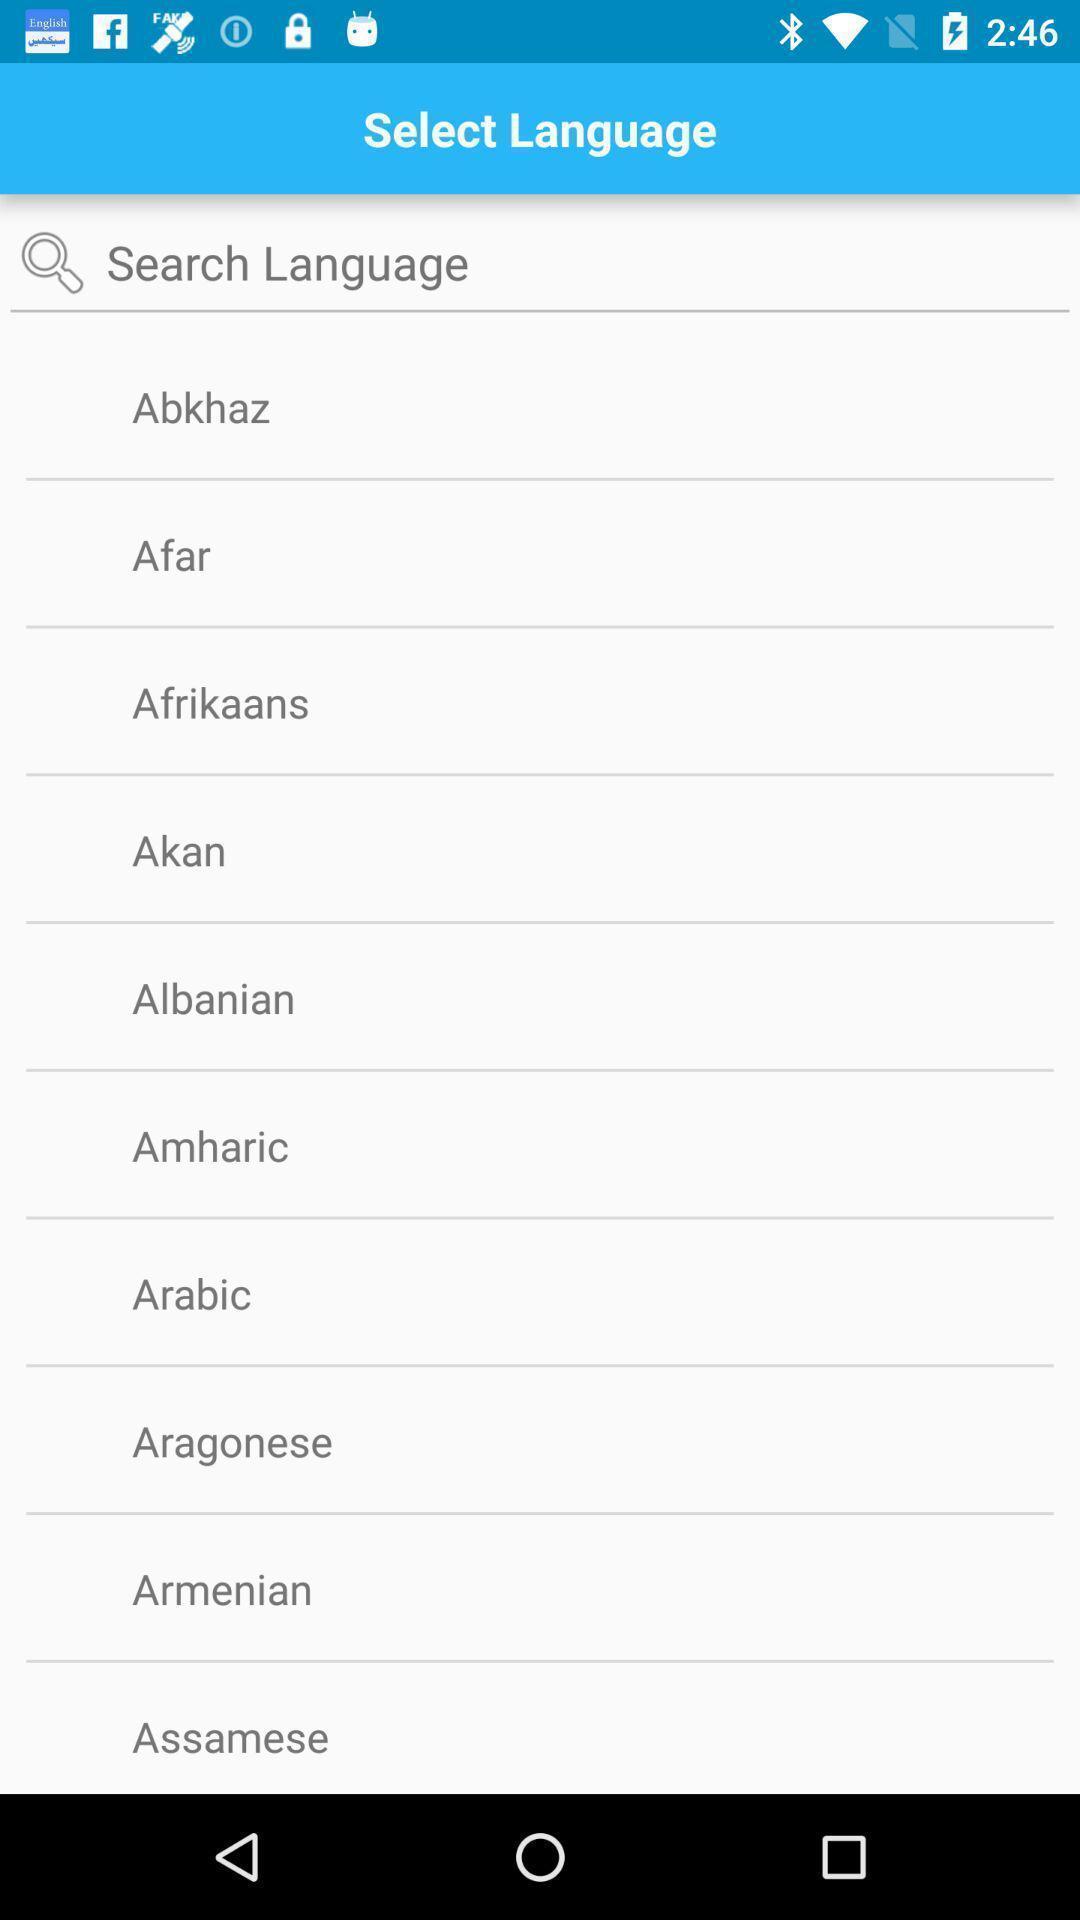Summarize the information in this screenshot. Page showing search bar to select language. 